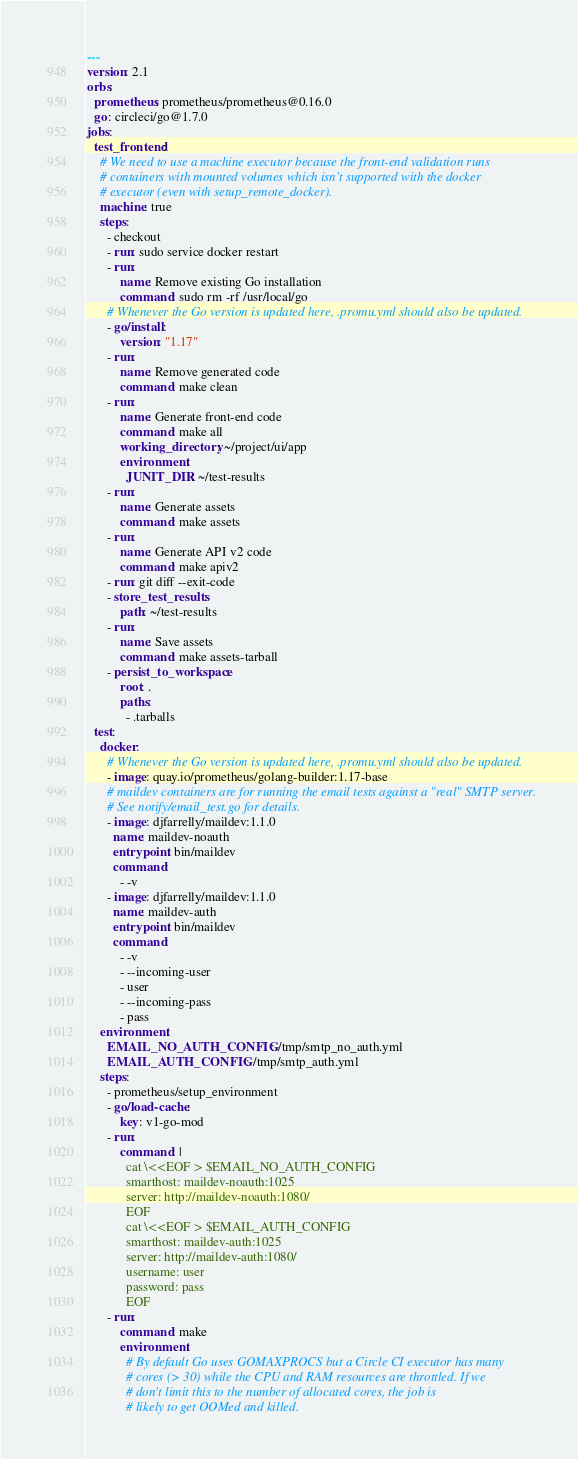Convert code to text. <code><loc_0><loc_0><loc_500><loc_500><_YAML_>---
version: 2.1
orbs:
  prometheus: prometheus/prometheus@0.16.0
  go: circleci/go@1.7.0
jobs:
  test_frontend:
    # We need to use a machine executor because the front-end validation runs
    # containers with mounted volumes which isn't supported with the docker
    # executor (even with setup_remote_docker).
    machine: true
    steps:
      - checkout
      - run: sudo service docker restart
      - run:
          name: Remove existing Go installation
          command: sudo rm -rf /usr/local/go
      # Whenever the Go version is updated here, .promu.yml should also be updated.
      - go/install:
          version: "1.17"
      - run:
          name: Remove generated code
          command: make clean
      - run:
          name: Generate front-end code
          command: make all
          working_directory: ~/project/ui/app
          environment:
            JUNIT_DIR: ~/test-results
      - run:
          name: Generate assets
          command: make assets
      - run:
          name: Generate API v2 code
          command: make apiv2
      - run: git diff --exit-code
      - store_test_results:
          path: ~/test-results
      - run:
          name: Save assets
          command: make assets-tarball
      - persist_to_workspace:
          root: .
          paths:
            - .tarballs
  test:
    docker:
      # Whenever the Go version is updated here, .promu.yml should also be updated.
      - image: quay.io/prometheus/golang-builder:1.17-base
      # maildev containers are for running the email tests against a "real" SMTP server.
      # See notify/email_test.go for details.
      - image: djfarrelly/maildev:1.1.0
        name: maildev-noauth
        entrypoint: bin/maildev
        command:
          - -v
      - image: djfarrelly/maildev:1.1.0
        name: maildev-auth
        entrypoint: bin/maildev
        command:
          - -v
          - --incoming-user
          - user
          - --incoming-pass
          - pass
    environment:
      EMAIL_NO_AUTH_CONFIG: /tmp/smtp_no_auth.yml
      EMAIL_AUTH_CONFIG: /tmp/smtp_auth.yml
    steps:
      - prometheus/setup_environment
      - go/load-cache:
          key: v1-go-mod
      - run:
          command: |
            cat \<<EOF > $EMAIL_NO_AUTH_CONFIG
            smarthost: maildev-noauth:1025
            server: http://maildev-noauth:1080/
            EOF
            cat \<<EOF > $EMAIL_AUTH_CONFIG
            smarthost: maildev-auth:1025
            server: http://maildev-auth:1080/
            username: user
            password: pass
            EOF
      - run:
          command: make
          environment:
            # By default Go uses GOMAXPROCS but a Circle CI executor has many
            # cores (> 30) while the CPU and RAM resources are throttled. If we
            # don't limit this to the number of allocated cores, the job is
            # likely to get OOMed and killed.</code> 